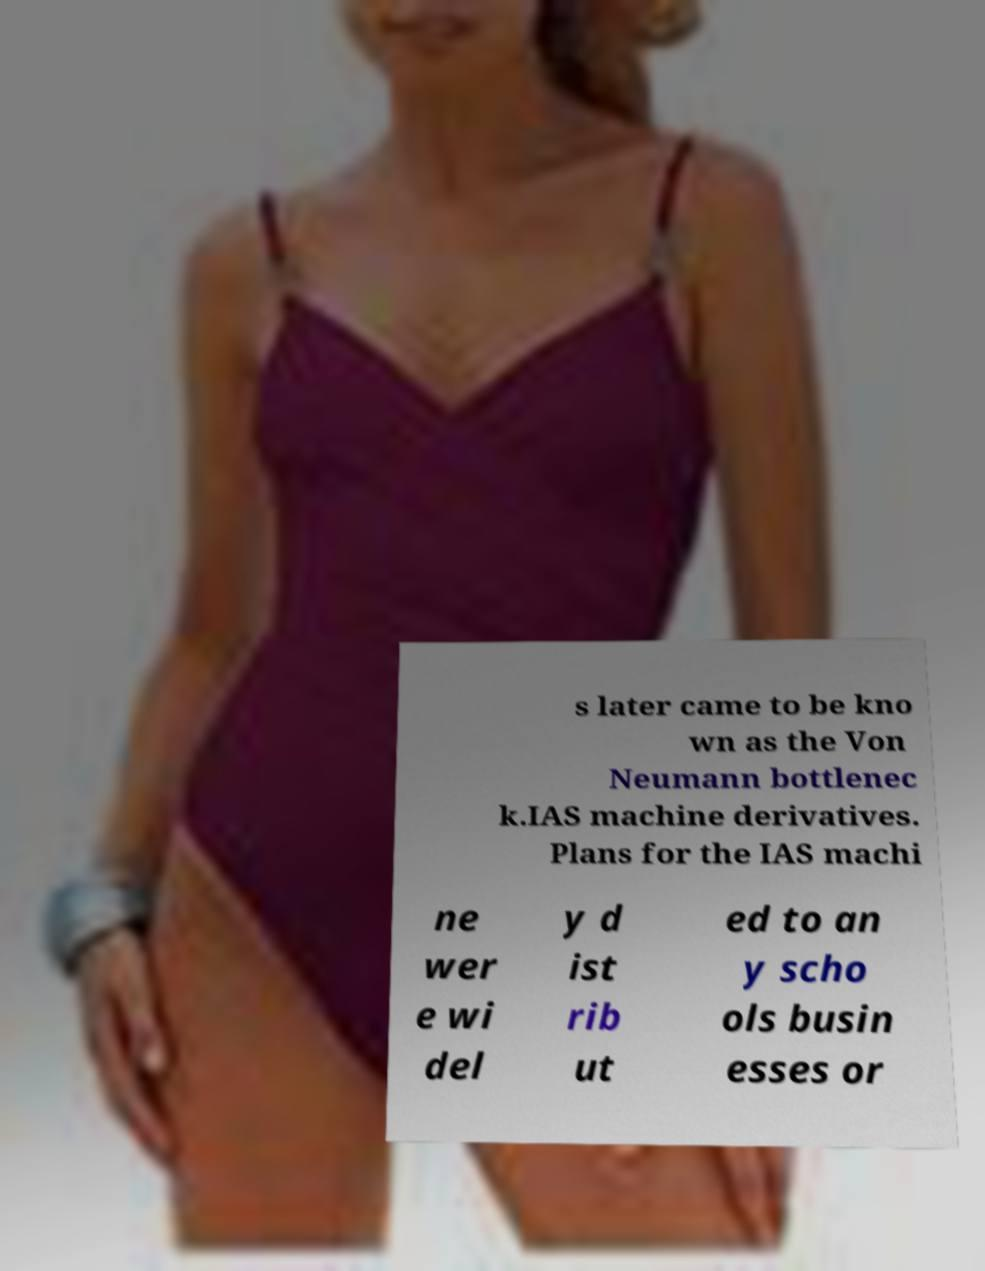There's text embedded in this image that I need extracted. Can you transcribe it verbatim? s later came to be kno wn as the Von Neumann bottlenec k.IAS machine derivatives. Plans for the IAS machi ne wer e wi del y d ist rib ut ed to an y scho ols busin esses or 